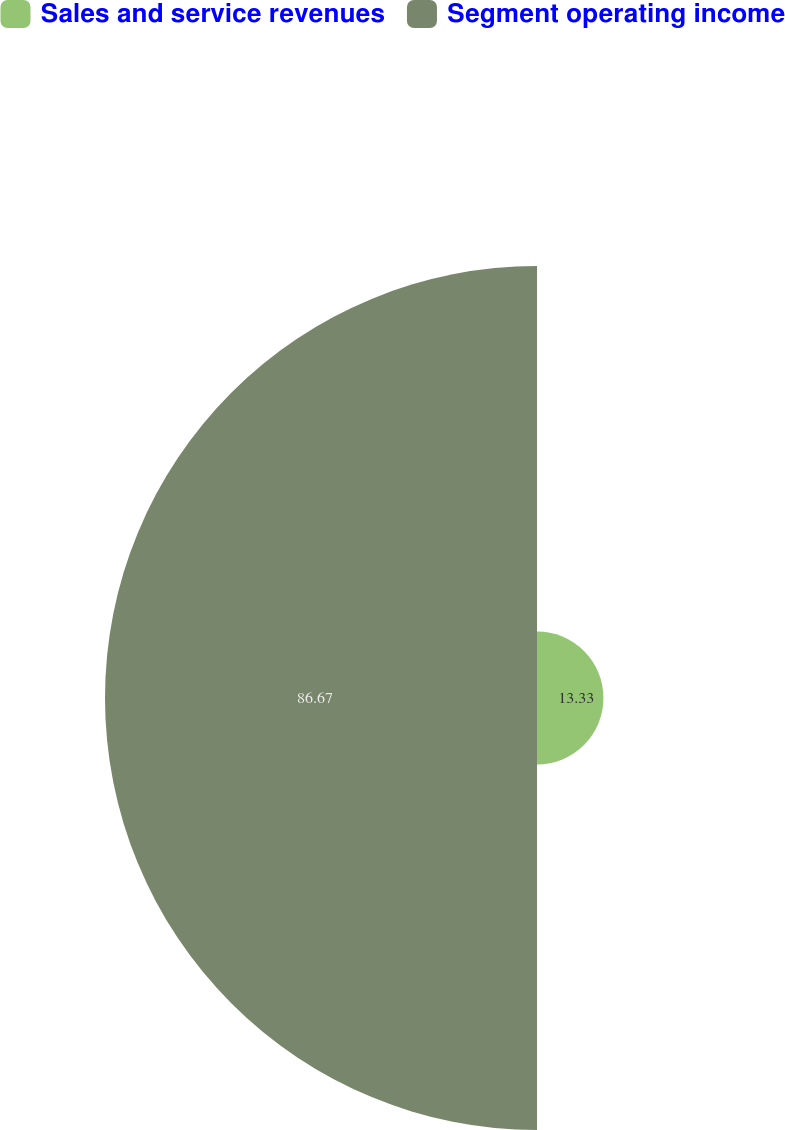<chart> <loc_0><loc_0><loc_500><loc_500><pie_chart><fcel>Sales and service revenues<fcel>Segment operating income<nl><fcel>13.33%<fcel>86.67%<nl></chart> 